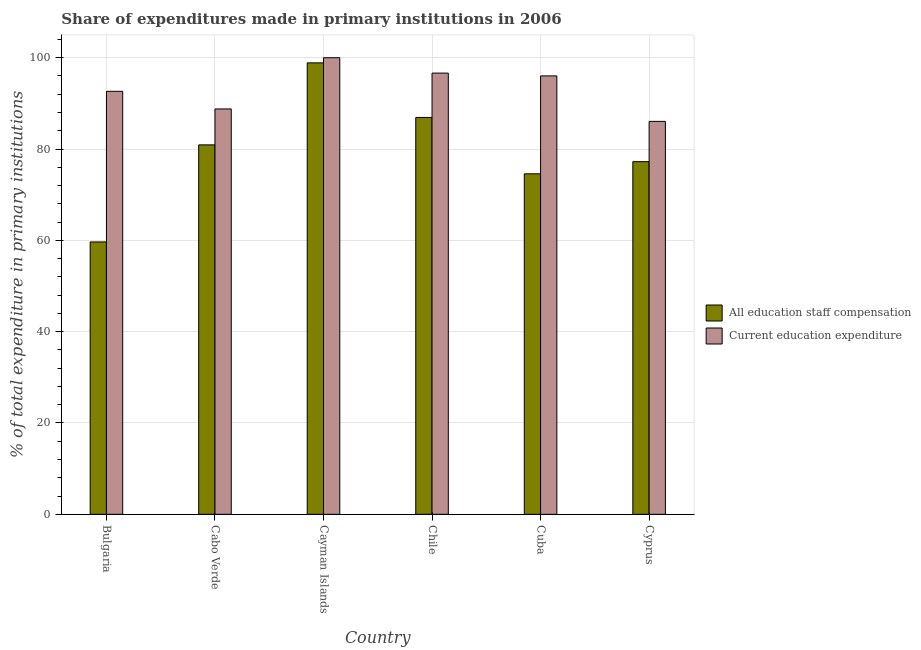How many bars are there on the 2nd tick from the right?
Your answer should be compact. 2. What is the label of the 5th group of bars from the left?
Provide a short and direct response. Cuba. In how many cases, is the number of bars for a given country not equal to the number of legend labels?
Your answer should be compact. 0. What is the expenditure in education in Chile?
Your answer should be compact. 96.63. Across all countries, what is the maximum expenditure in staff compensation?
Offer a very short reply. 98.87. Across all countries, what is the minimum expenditure in staff compensation?
Keep it short and to the point. 59.65. In which country was the expenditure in staff compensation maximum?
Provide a succinct answer. Cayman Islands. What is the total expenditure in education in the graph?
Make the answer very short. 560.12. What is the difference between the expenditure in staff compensation in Bulgaria and that in Cabo Verde?
Provide a succinct answer. -21.26. What is the difference between the expenditure in education in Bulgaria and the expenditure in staff compensation in Cuba?
Keep it short and to the point. 18.07. What is the average expenditure in education per country?
Provide a short and direct response. 93.35. What is the difference between the expenditure in staff compensation and expenditure in education in Chile?
Your answer should be compact. -9.71. What is the ratio of the expenditure in staff compensation in Chile to that in Cyprus?
Provide a succinct answer. 1.13. Is the expenditure in staff compensation in Cabo Verde less than that in Chile?
Your answer should be compact. Yes. Is the difference between the expenditure in education in Chile and Cyprus greater than the difference between the expenditure in staff compensation in Chile and Cyprus?
Provide a succinct answer. Yes. What is the difference between the highest and the second highest expenditure in staff compensation?
Your response must be concise. 11.95. What is the difference between the highest and the lowest expenditure in education?
Offer a terse response. 13.94. In how many countries, is the expenditure in staff compensation greater than the average expenditure in staff compensation taken over all countries?
Offer a very short reply. 3. Is the sum of the expenditure in staff compensation in Cayman Islands and Cyprus greater than the maximum expenditure in education across all countries?
Your answer should be compact. Yes. What does the 1st bar from the left in Cabo Verde represents?
Provide a short and direct response. All education staff compensation. What does the 1st bar from the right in Cuba represents?
Provide a short and direct response. Current education expenditure. How many bars are there?
Your response must be concise. 12. Are all the bars in the graph horizontal?
Give a very brief answer. No. How many countries are there in the graph?
Your response must be concise. 6. What is the difference between two consecutive major ticks on the Y-axis?
Offer a terse response. 20. Are the values on the major ticks of Y-axis written in scientific E-notation?
Make the answer very short. No. Does the graph contain grids?
Give a very brief answer. Yes. Where does the legend appear in the graph?
Your answer should be compact. Center right. How many legend labels are there?
Your answer should be compact. 2. What is the title of the graph?
Your answer should be compact. Share of expenditures made in primary institutions in 2006. Does "Netherlands" appear as one of the legend labels in the graph?
Keep it short and to the point. No. What is the label or title of the X-axis?
Give a very brief answer. Country. What is the label or title of the Y-axis?
Make the answer very short. % of total expenditure in primary institutions. What is the % of total expenditure in primary institutions in All education staff compensation in Bulgaria?
Ensure brevity in your answer.  59.65. What is the % of total expenditure in primary institutions in Current education expenditure in Bulgaria?
Give a very brief answer. 92.64. What is the % of total expenditure in primary institutions in All education staff compensation in Cabo Verde?
Offer a terse response. 80.91. What is the % of total expenditure in primary institutions in Current education expenditure in Cabo Verde?
Your response must be concise. 88.78. What is the % of total expenditure in primary institutions of All education staff compensation in Cayman Islands?
Give a very brief answer. 98.87. What is the % of total expenditure in primary institutions in All education staff compensation in Chile?
Your answer should be very brief. 86.92. What is the % of total expenditure in primary institutions of Current education expenditure in Chile?
Provide a succinct answer. 96.63. What is the % of total expenditure in primary institutions of All education staff compensation in Cuba?
Offer a very short reply. 74.57. What is the % of total expenditure in primary institutions in Current education expenditure in Cuba?
Provide a short and direct response. 96.02. What is the % of total expenditure in primary institutions in All education staff compensation in Cyprus?
Give a very brief answer. 77.24. What is the % of total expenditure in primary institutions of Current education expenditure in Cyprus?
Give a very brief answer. 86.06. Across all countries, what is the maximum % of total expenditure in primary institutions of All education staff compensation?
Your answer should be compact. 98.87. Across all countries, what is the maximum % of total expenditure in primary institutions in Current education expenditure?
Your answer should be very brief. 100. Across all countries, what is the minimum % of total expenditure in primary institutions of All education staff compensation?
Give a very brief answer. 59.65. Across all countries, what is the minimum % of total expenditure in primary institutions of Current education expenditure?
Your response must be concise. 86.06. What is the total % of total expenditure in primary institutions of All education staff compensation in the graph?
Your response must be concise. 478.16. What is the total % of total expenditure in primary institutions in Current education expenditure in the graph?
Make the answer very short. 560.12. What is the difference between the % of total expenditure in primary institutions in All education staff compensation in Bulgaria and that in Cabo Verde?
Your answer should be very brief. -21.26. What is the difference between the % of total expenditure in primary institutions in Current education expenditure in Bulgaria and that in Cabo Verde?
Keep it short and to the point. 3.86. What is the difference between the % of total expenditure in primary institutions in All education staff compensation in Bulgaria and that in Cayman Islands?
Your answer should be very brief. -39.22. What is the difference between the % of total expenditure in primary institutions of Current education expenditure in Bulgaria and that in Cayman Islands?
Offer a very short reply. -7.36. What is the difference between the % of total expenditure in primary institutions in All education staff compensation in Bulgaria and that in Chile?
Make the answer very short. -27.26. What is the difference between the % of total expenditure in primary institutions of Current education expenditure in Bulgaria and that in Chile?
Offer a very short reply. -3.99. What is the difference between the % of total expenditure in primary institutions of All education staff compensation in Bulgaria and that in Cuba?
Your answer should be compact. -14.92. What is the difference between the % of total expenditure in primary institutions in Current education expenditure in Bulgaria and that in Cuba?
Your answer should be compact. -3.37. What is the difference between the % of total expenditure in primary institutions of All education staff compensation in Bulgaria and that in Cyprus?
Your answer should be compact. -17.58. What is the difference between the % of total expenditure in primary institutions in Current education expenditure in Bulgaria and that in Cyprus?
Make the answer very short. 6.59. What is the difference between the % of total expenditure in primary institutions in All education staff compensation in Cabo Verde and that in Cayman Islands?
Provide a succinct answer. -17.96. What is the difference between the % of total expenditure in primary institutions in Current education expenditure in Cabo Verde and that in Cayman Islands?
Keep it short and to the point. -11.22. What is the difference between the % of total expenditure in primary institutions in All education staff compensation in Cabo Verde and that in Chile?
Ensure brevity in your answer.  -6. What is the difference between the % of total expenditure in primary institutions in Current education expenditure in Cabo Verde and that in Chile?
Give a very brief answer. -7.85. What is the difference between the % of total expenditure in primary institutions in All education staff compensation in Cabo Verde and that in Cuba?
Your response must be concise. 6.34. What is the difference between the % of total expenditure in primary institutions in Current education expenditure in Cabo Verde and that in Cuba?
Your answer should be compact. -7.24. What is the difference between the % of total expenditure in primary institutions in All education staff compensation in Cabo Verde and that in Cyprus?
Provide a succinct answer. 3.68. What is the difference between the % of total expenditure in primary institutions of Current education expenditure in Cabo Verde and that in Cyprus?
Your response must be concise. 2.72. What is the difference between the % of total expenditure in primary institutions of All education staff compensation in Cayman Islands and that in Chile?
Offer a very short reply. 11.95. What is the difference between the % of total expenditure in primary institutions of Current education expenditure in Cayman Islands and that in Chile?
Your response must be concise. 3.37. What is the difference between the % of total expenditure in primary institutions in All education staff compensation in Cayman Islands and that in Cuba?
Provide a short and direct response. 24.3. What is the difference between the % of total expenditure in primary institutions of Current education expenditure in Cayman Islands and that in Cuba?
Offer a terse response. 3.98. What is the difference between the % of total expenditure in primary institutions in All education staff compensation in Cayman Islands and that in Cyprus?
Offer a very short reply. 21.64. What is the difference between the % of total expenditure in primary institutions in Current education expenditure in Cayman Islands and that in Cyprus?
Keep it short and to the point. 13.94. What is the difference between the % of total expenditure in primary institutions in All education staff compensation in Chile and that in Cuba?
Your answer should be very brief. 12.35. What is the difference between the % of total expenditure in primary institutions in Current education expenditure in Chile and that in Cuba?
Ensure brevity in your answer.  0.61. What is the difference between the % of total expenditure in primary institutions in All education staff compensation in Chile and that in Cyprus?
Provide a succinct answer. 9.68. What is the difference between the % of total expenditure in primary institutions of Current education expenditure in Chile and that in Cyprus?
Your answer should be compact. 10.57. What is the difference between the % of total expenditure in primary institutions in All education staff compensation in Cuba and that in Cyprus?
Your response must be concise. -2.67. What is the difference between the % of total expenditure in primary institutions in Current education expenditure in Cuba and that in Cyprus?
Keep it short and to the point. 9.96. What is the difference between the % of total expenditure in primary institutions in All education staff compensation in Bulgaria and the % of total expenditure in primary institutions in Current education expenditure in Cabo Verde?
Ensure brevity in your answer.  -29.13. What is the difference between the % of total expenditure in primary institutions in All education staff compensation in Bulgaria and the % of total expenditure in primary institutions in Current education expenditure in Cayman Islands?
Provide a succinct answer. -40.35. What is the difference between the % of total expenditure in primary institutions in All education staff compensation in Bulgaria and the % of total expenditure in primary institutions in Current education expenditure in Chile?
Your answer should be compact. -36.98. What is the difference between the % of total expenditure in primary institutions of All education staff compensation in Bulgaria and the % of total expenditure in primary institutions of Current education expenditure in Cuba?
Your answer should be compact. -36.36. What is the difference between the % of total expenditure in primary institutions in All education staff compensation in Bulgaria and the % of total expenditure in primary institutions in Current education expenditure in Cyprus?
Your answer should be very brief. -26.4. What is the difference between the % of total expenditure in primary institutions of All education staff compensation in Cabo Verde and the % of total expenditure in primary institutions of Current education expenditure in Cayman Islands?
Your answer should be very brief. -19.09. What is the difference between the % of total expenditure in primary institutions in All education staff compensation in Cabo Verde and the % of total expenditure in primary institutions in Current education expenditure in Chile?
Give a very brief answer. -15.72. What is the difference between the % of total expenditure in primary institutions of All education staff compensation in Cabo Verde and the % of total expenditure in primary institutions of Current education expenditure in Cuba?
Offer a terse response. -15.1. What is the difference between the % of total expenditure in primary institutions of All education staff compensation in Cabo Verde and the % of total expenditure in primary institutions of Current education expenditure in Cyprus?
Provide a succinct answer. -5.14. What is the difference between the % of total expenditure in primary institutions of All education staff compensation in Cayman Islands and the % of total expenditure in primary institutions of Current education expenditure in Chile?
Ensure brevity in your answer.  2.24. What is the difference between the % of total expenditure in primary institutions of All education staff compensation in Cayman Islands and the % of total expenditure in primary institutions of Current education expenditure in Cuba?
Keep it short and to the point. 2.86. What is the difference between the % of total expenditure in primary institutions of All education staff compensation in Cayman Islands and the % of total expenditure in primary institutions of Current education expenditure in Cyprus?
Your answer should be compact. 12.82. What is the difference between the % of total expenditure in primary institutions of All education staff compensation in Chile and the % of total expenditure in primary institutions of Current education expenditure in Cuba?
Ensure brevity in your answer.  -9.1. What is the difference between the % of total expenditure in primary institutions of All education staff compensation in Chile and the % of total expenditure in primary institutions of Current education expenditure in Cyprus?
Your response must be concise. 0.86. What is the difference between the % of total expenditure in primary institutions in All education staff compensation in Cuba and the % of total expenditure in primary institutions in Current education expenditure in Cyprus?
Provide a short and direct response. -11.49. What is the average % of total expenditure in primary institutions in All education staff compensation per country?
Offer a terse response. 79.69. What is the average % of total expenditure in primary institutions in Current education expenditure per country?
Offer a very short reply. 93.35. What is the difference between the % of total expenditure in primary institutions in All education staff compensation and % of total expenditure in primary institutions in Current education expenditure in Bulgaria?
Keep it short and to the point. -32.99. What is the difference between the % of total expenditure in primary institutions in All education staff compensation and % of total expenditure in primary institutions in Current education expenditure in Cabo Verde?
Offer a terse response. -7.87. What is the difference between the % of total expenditure in primary institutions in All education staff compensation and % of total expenditure in primary institutions in Current education expenditure in Cayman Islands?
Your answer should be very brief. -1.13. What is the difference between the % of total expenditure in primary institutions of All education staff compensation and % of total expenditure in primary institutions of Current education expenditure in Chile?
Ensure brevity in your answer.  -9.71. What is the difference between the % of total expenditure in primary institutions in All education staff compensation and % of total expenditure in primary institutions in Current education expenditure in Cuba?
Offer a very short reply. -21.45. What is the difference between the % of total expenditure in primary institutions in All education staff compensation and % of total expenditure in primary institutions in Current education expenditure in Cyprus?
Offer a terse response. -8.82. What is the ratio of the % of total expenditure in primary institutions in All education staff compensation in Bulgaria to that in Cabo Verde?
Your answer should be very brief. 0.74. What is the ratio of the % of total expenditure in primary institutions of Current education expenditure in Bulgaria to that in Cabo Verde?
Keep it short and to the point. 1.04. What is the ratio of the % of total expenditure in primary institutions of All education staff compensation in Bulgaria to that in Cayman Islands?
Provide a succinct answer. 0.6. What is the ratio of the % of total expenditure in primary institutions in Current education expenditure in Bulgaria to that in Cayman Islands?
Provide a short and direct response. 0.93. What is the ratio of the % of total expenditure in primary institutions of All education staff compensation in Bulgaria to that in Chile?
Your answer should be very brief. 0.69. What is the ratio of the % of total expenditure in primary institutions of Current education expenditure in Bulgaria to that in Chile?
Provide a succinct answer. 0.96. What is the ratio of the % of total expenditure in primary institutions in Current education expenditure in Bulgaria to that in Cuba?
Offer a terse response. 0.96. What is the ratio of the % of total expenditure in primary institutions of All education staff compensation in Bulgaria to that in Cyprus?
Provide a succinct answer. 0.77. What is the ratio of the % of total expenditure in primary institutions of Current education expenditure in Bulgaria to that in Cyprus?
Offer a very short reply. 1.08. What is the ratio of the % of total expenditure in primary institutions of All education staff compensation in Cabo Verde to that in Cayman Islands?
Provide a short and direct response. 0.82. What is the ratio of the % of total expenditure in primary institutions of Current education expenditure in Cabo Verde to that in Cayman Islands?
Offer a very short reply. 0.89. What is the ratio of the % of total expenditure in primary institutions in All education staff compensation in Cabo Verde to that in Chile?
Your response must be concise. 0.93. What is the ratio of the % of total expenditure in primary institutions of Current education expenditure in Cabo Verde to that in Chile?
Provide a short and direct response. 0.92. What is the ratio of the % of total expenditure in primary institutions in All education staff compensation in Cabo Verde to that in Cuba?
Your answer should be very brief. 1.09. What is the ratio of the % of total expenditure in primary institutions of Current education expenditure in Cabo Verde to that in Cuba?
Offer a terse response. 0.92. What is the ratio of the % of total expenditure in primary institutions of All education staff compensation in Cabo Verde to that in Cyprus?
Give a very brief answer. 1.05. What is the ratio of the % of total expenditure in primary institutions in Current education expenditure in Cabo Verde to that in Cyprus?
Make the answer very short. 1.03. What is the ratio of the % of total expenditure in primary institutions in All education staff compensation in Cayman Islands to that in Chile?
Your answer should be compact. 1.14. What is the ratio of the % of total expenditure in primary institutions of Current education expenditure in Cayman Islands to that in Chile?
Keep it short and to the point. 1.03. What is the ratio of the % of total expenditure in primary institutions in All education staff compensation in Cayman Islands to that in Cuba?
Offer a very short reply. 1.33. What is the ratio of the % of total expenditure in primary institutions of Current education expenditure in Cayman Islands to that in Cuba?
Offer a very short reply. 1.04. What is the ratio of the % of total expenditure in primary institutions of All education staff compensation in Cayman Islands to that in Cyprus?
Offer a terse response. 1.28. What is the ratio of the % of total expenditure in primary institutions in Current education expenditure in Cayman Islands to that in Cyprus?
Provide a succinct answer. 1.16. What is the ratio of the % of total expenditure in primary institutions of All education staff compensation in Chile to that in Cuba?
Provide a short and direct response. 1.17. What is the ratio of the % of total expenditure in primary institutions of Current education expenditure in Chile to that in Cuba?
Keep it short and to the point. 1.01. What is the ratio of the % of total expenditure in primary institutions of All education staff compensation in Chile to that in Cyprus?
Offer a very short reply. 1.13. What is the ratio of the % of total expenditure in primary institutions in Current education expenditure in Chile to that in Cyprus?
Offer a very short reply. 1.12. What is the ratio of the % of total expenditure in primary institutions in All education staff compensation in Cuba to that in Cyprus?
Keep it short and to the point. 0.97. What is the ratio of the % of total expenditure in primary institutions in Current education expenditure in Cuba to that in Cyprus?
Keep it short and to the point. 1.12. What is the difference between the highest and the second highest % of total expenditure in primary institutions in All education staff compensation?
Ensure brevity in your answer.  11.95. What is the difference between the highest and the second highest % of total expenditure in primary institutions in Current education expenditure?
Ensure brevity in your answer.  3.37. What is the difference between the highest and the lowest % of total expenditure in primary institutions of All education staff compensation?
Provide a succinct answer. 39.22. What is the difference between the highest and the lowest % of total expenditure in primary institutions of Current education expenditure?
Provide a succinct answer. 13.94. 